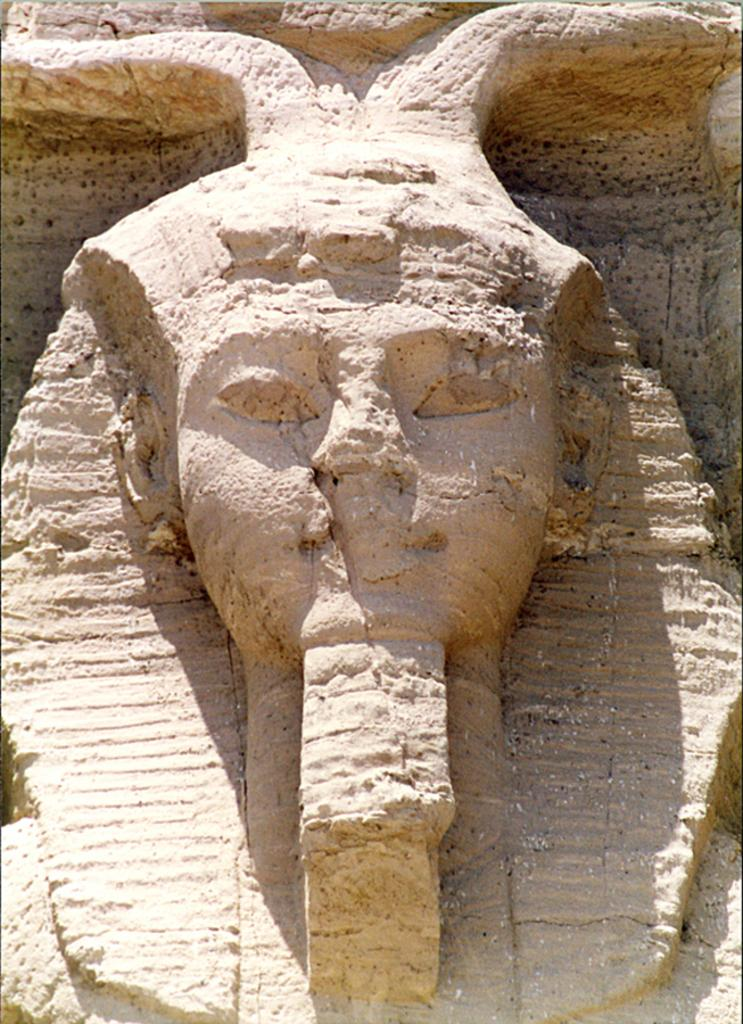What is the main subject of the image? The main subject of the image is a rock. Is there anything unique about the rock? Yes, the rock has a sculpture of a person. What type of station is depicted in the image? There is no station present in the image; it features a rock with a sculpture of a person. How does the brake system work on the rock in the image? There is no brake system present on the rock, as it is a sculpture and not a vehicle. 